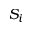Convert formula to latex. <formula><loc_0><loc_0><loc_500><loc_500>S _ { i }</formula> 